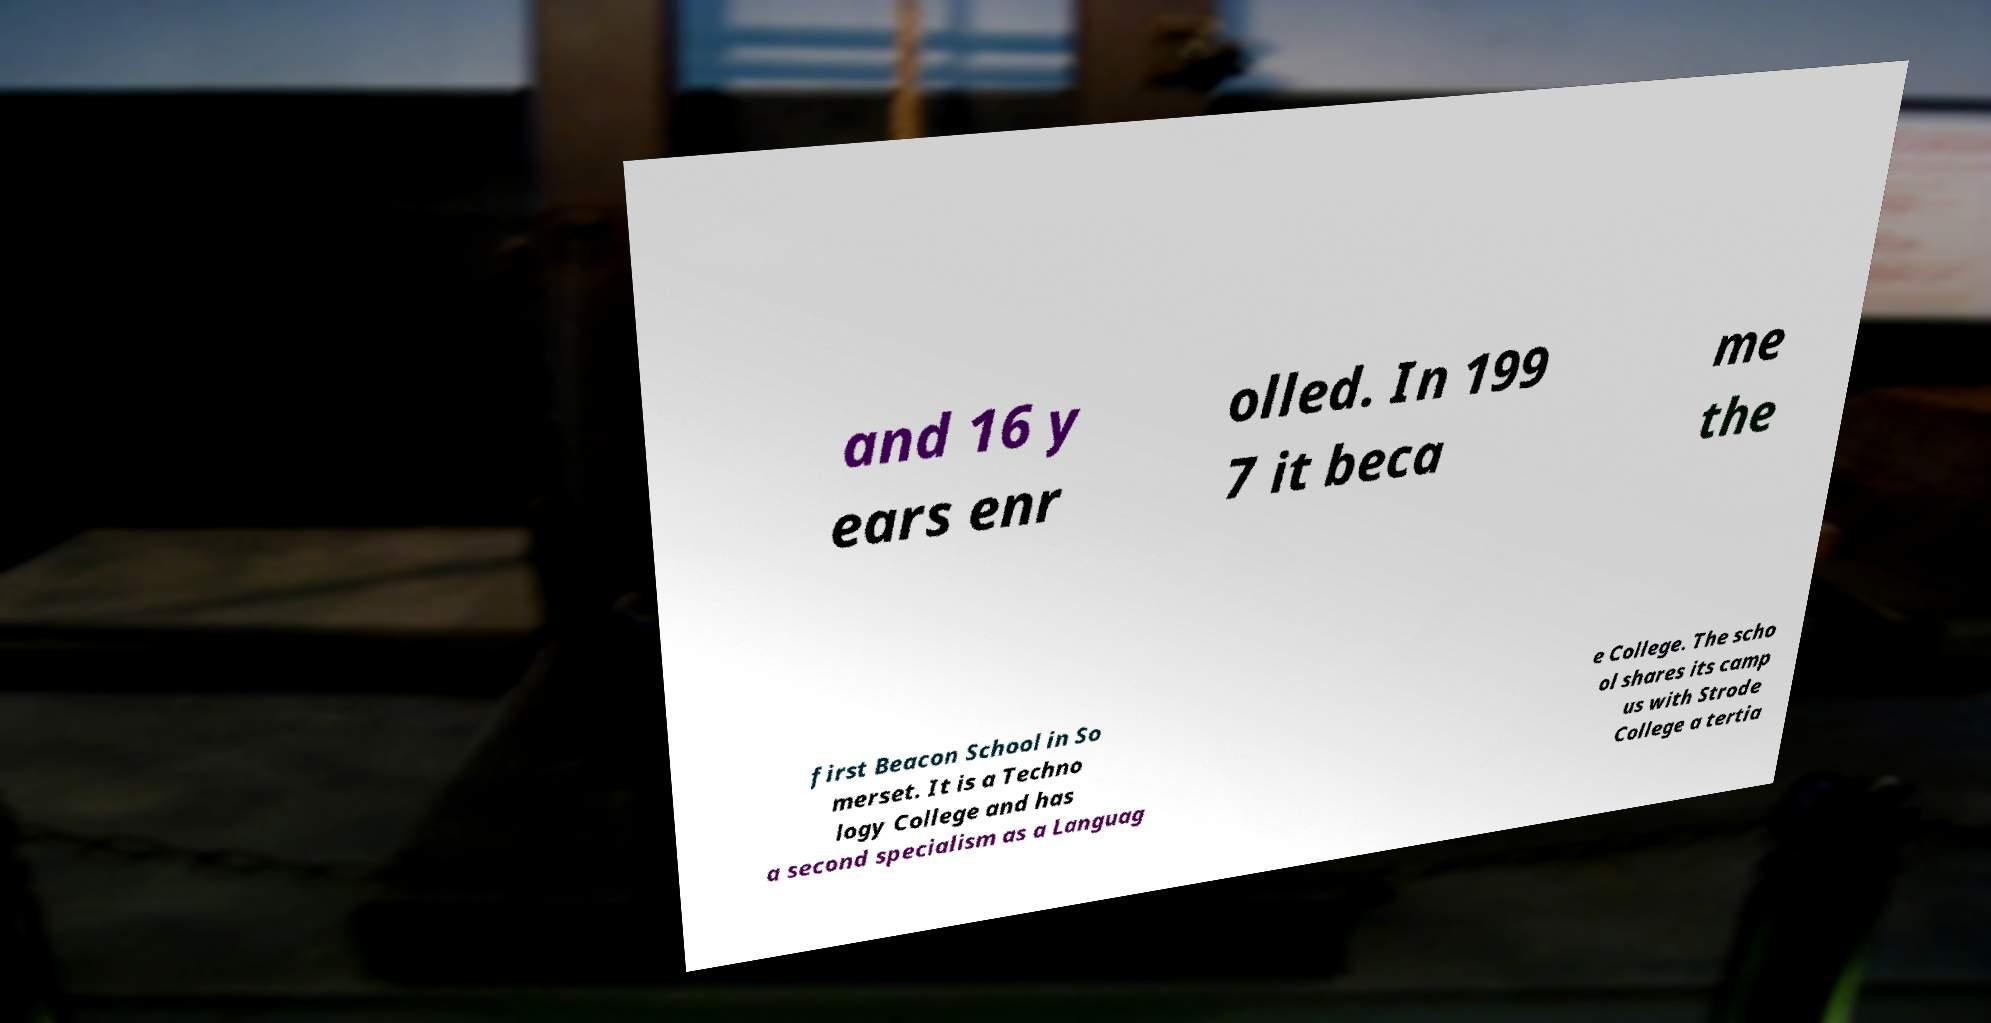For documentation purposes, I need the text within this image transcribed. Could you provide that? and 16 y ears enr olled. In 199 7 it beca me the first Beacon School in So merset. It is a Techno logy College and has a second specialism as a Languag e College. The scho ol shares its camp us with Strode College a tertia 